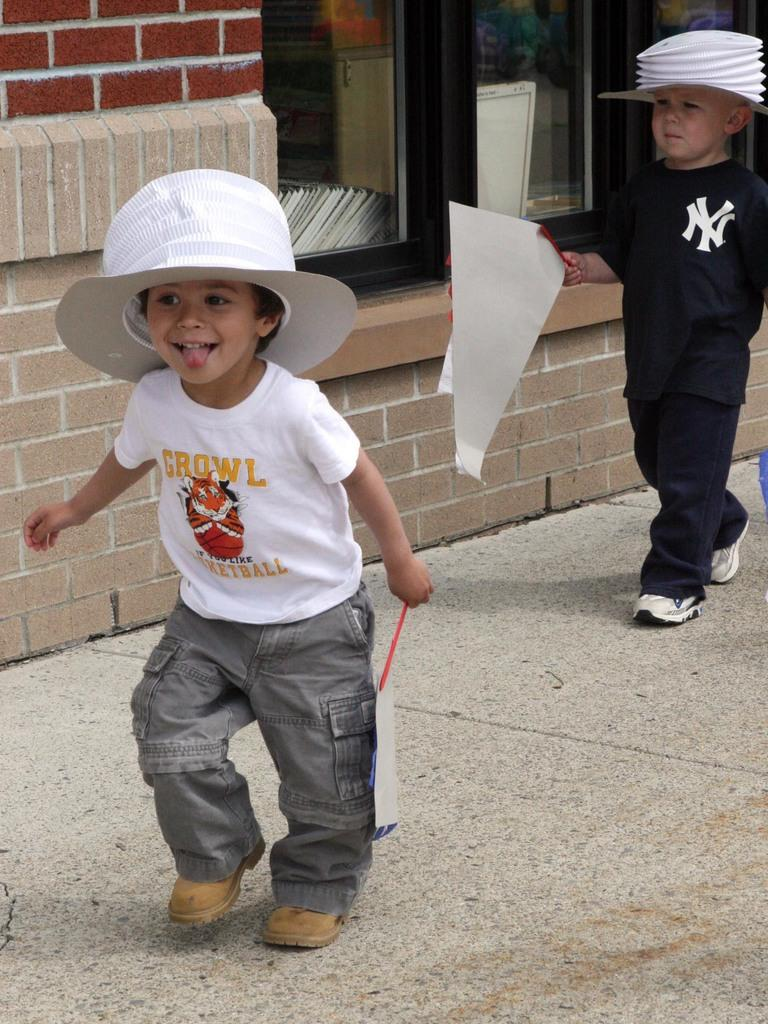How many children are in the image? There are two children in the image. What are the children wearing? The children are wearing clothes, and one child is wearing a cap while the other is wearing a hat. What type of footwear are the children wearing? Both children are wearing shoes. What are the children holding in their hands? The children are holding an object in their hands. What can be seen in the background of the image? There is a footpath and a window in the image. What type of sea creature can be seen swimming in the image? There is no sea creature present in the image; it features two children and a footpath. What type of dinner is being served in the image? There is no dinner being served in the image; it only shows two children and their clothing and accessories. 